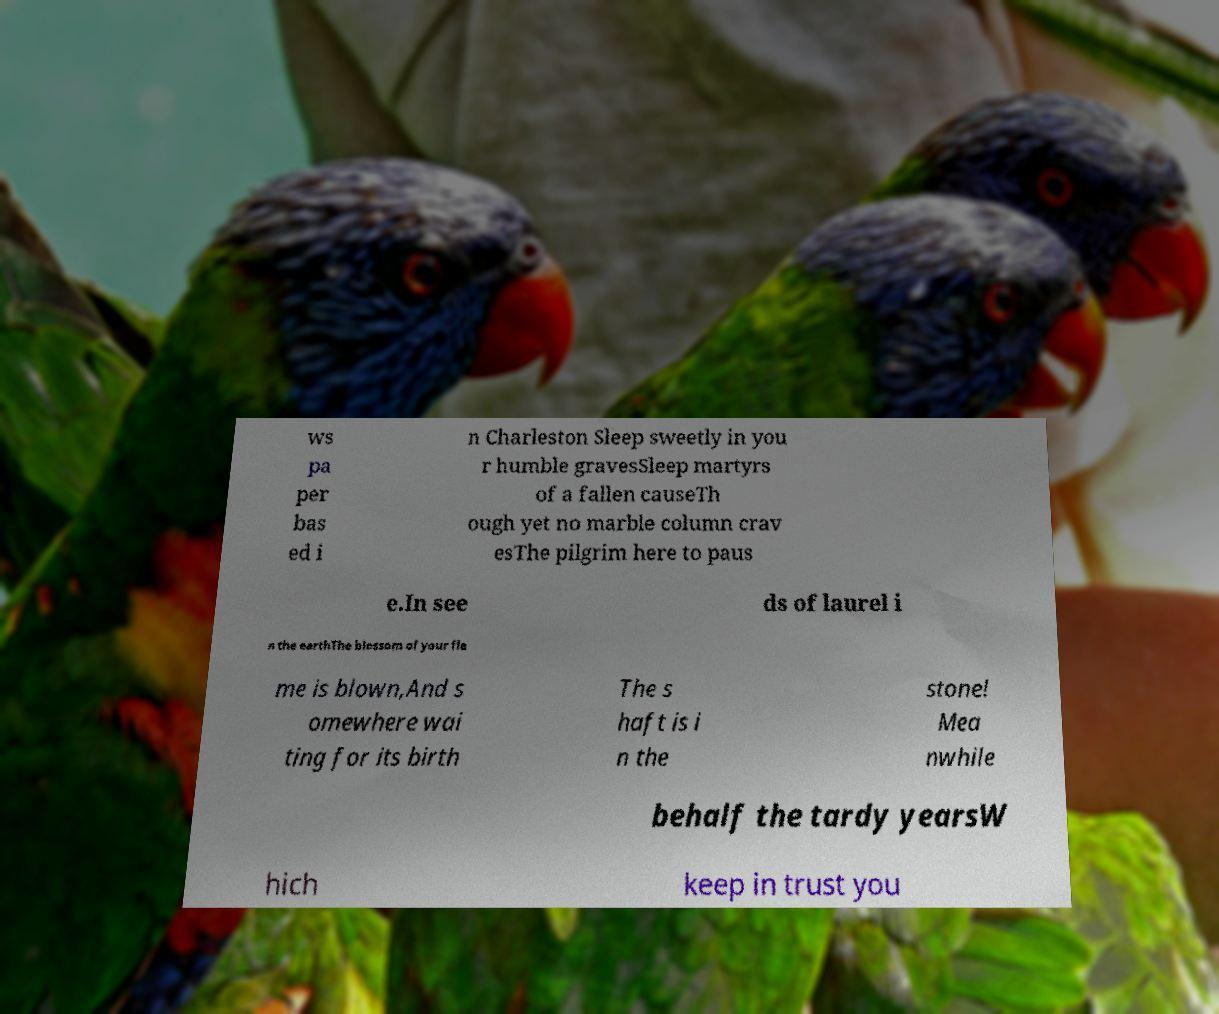Could you extract and type out the text from this image? ws pa per bas ed i n Charleston Sleep sweetly in you r humble gravesSleep martyrs of a fallen causeTh ough yet no marble column crav esThe pilgrim here to paus e.In see ds of laurel i n the earthThe blossom of your fla me is blown,And s omewhere wai ting for its birth The s haft is i n the stone! Mea nwhile behalf the tardy yearsW hich keep in trust you 